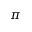Convert formula to latex. <formula><loc_0><loc_0><loc_500><loc_500>\pi</formula> 